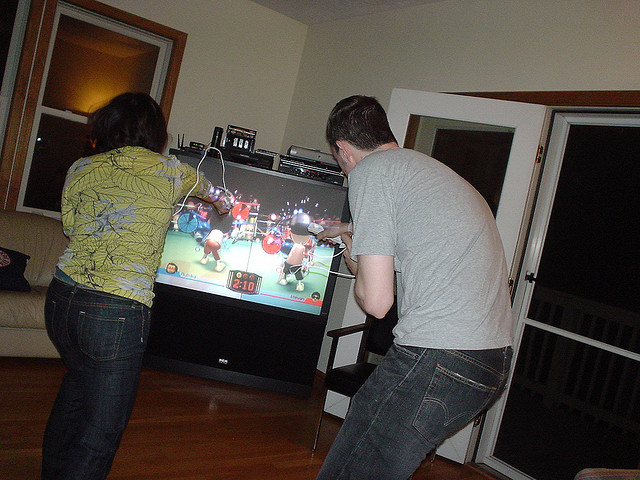Read and extract the text from this image. 2:10 